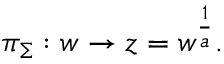<formula> <loc_0><loc_0><loc_500><loc_500>\pi _ { \Sigma } \colon w \to z = w ^ { { \frac { 1 } { a } } } .</formula> 